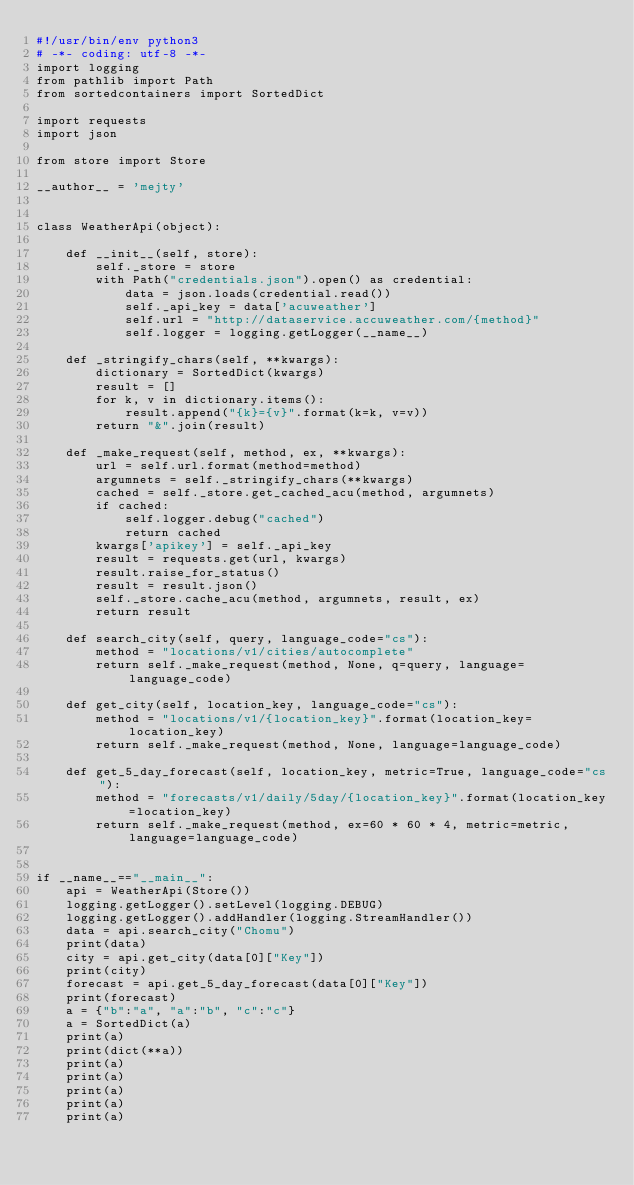<code> <loc_0><loc_0><loc_500><loc_500><_Python_>#!/usr/bin/env python3
# -*- coding: utf-8 -*-
import logging
from pathlib import Path
from sortedcontainers import SortedDict

import requests
import json

from store import Store

__author__ = 'mejty'


class WeatherApi(object):

    def __init__(self, store):
        self._store = store
        with Path("credentials.json").open() as credential:
            data = json.loads(credential.read())
            self._api_key = data['acuweather']
            self.url = "http://dataservice.accuweather.com/{method}"
            self.logger = logging.getLogger(__name__)

    def _stringify_chars(self, **kwargs):
        dictionary = SortedDict(kwargs)
        result = []
        for k, v in dictionary.items():
            result.append("{k}={v}".format(k=k, v=v))
        return "&".join(result)

    def _make_request(self, method, ex, **kwargs):
        url = self.url.format(method=method)
        argumnets = self._stringify_chars(**kwargs)
        cached = self._store.get_cached_acu(method, argumnets)
        if cached:
            self.logger.debug("cached")
            return cached
        kwargs['apikey'] = self._api_key
        result = requests.get(url, kwargs)
        result.raise_for_status()
        result = result.json()
        self._store.cache_acu(method, argumnets, result, ex)
        return result

    def search_city(self, query, language_code="cs"):
        method = "locations/v1/cities/autocomplete"
        return self._make_request(method, None, q=query, language=language_code)

    def get_city(self, location_key, language_code="cs"):
        method = "locations/v1/{location_key}".format(location_key=location_key)
        return self._make_request(method, None, language=language_code)

    def get_5_day_forecast(self, location_key, metric=True, language_code="cs"):
        method = "forecasts/v1/daily/5day/{location_key}".format(location_key=location_key)
        return self._make_request(method, ex=60 * 60 * 4, metric=metric, language=language_code)


if __name__=="__main__":
    api = WeatherApi(Store())
    logging.getLogger().setLevel(logging.DEBUG)
    logging.getLogger().addHandler(logging.StreamHandler())
    data = api.search_city("Chomu")
    print(data)
    city = api.get_city(data[0]["Key"])
    print(city)
    forecast = api.get_5_day_forecast(data[0]["Key"])
    print(forecast)
    a = {"b":"a", "a":"b", "c":"c"}
    a = SortedDict(a)
    print(a)
    print(dict(**a))
    print(a)
    print(a)
    print(a)
    print(a)
    print(a)
</code> 